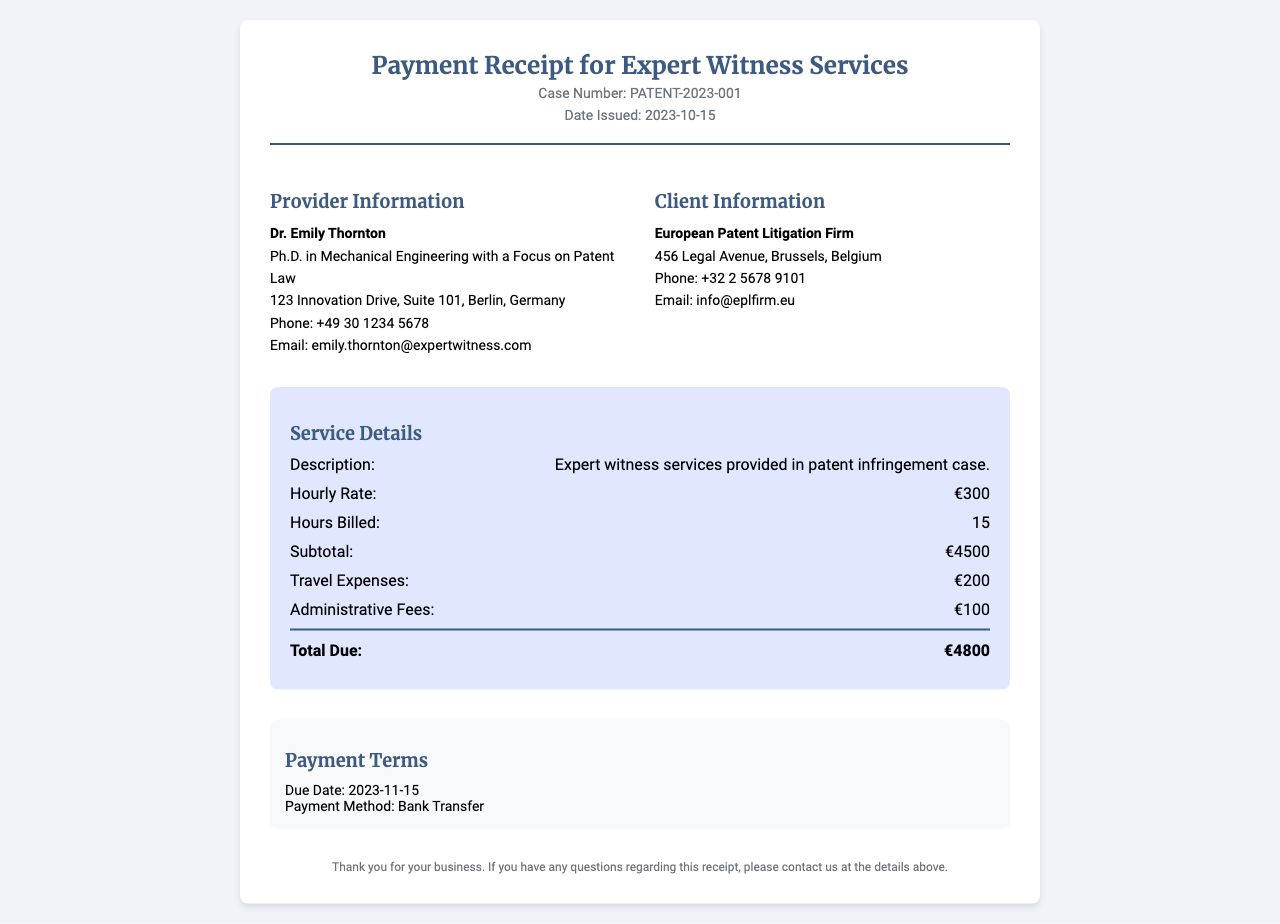What is the case number? The case number is listed under the header of the receipt.
Answer: PATENT-2023-001 What is the date issued? The date issued is provided in the header section.
Answer: 2023-10-15 Who is the provider of the expert witness services? The provider's information is in the "Provider Information" section of the document.
Answer: Dr. Emily Thornton What is the hourly rate for the services? The hourly rate is mentioned in the service details section.
Answer: €300 How many hours were billed? The number of hours billed is specified in the service details section.
Answer: 15 What are the travel expenses? Travel expenses are listed within the service details.
Answer: €200 What is the total due amount? The total due is at the end of the service details section.
Answer: €4800 What is the payment method? The payment method is found in the payment terms section of the document.
Answer: Bank Transfer When is the due date for payment? The due date for payment is stated in the payment terms section.
Answer: 2023-11-15 